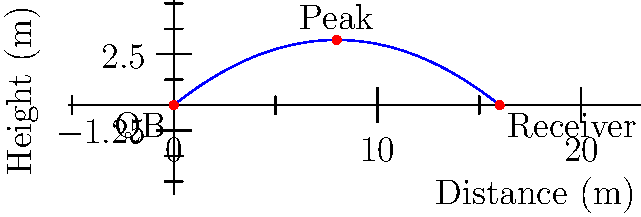A Howard Bison quarterback throws a football with an initial velocity of 20 m/s at an angle of 30° above the horizontal. Assuming air resistance is negligible, what is the maximum height reached by the football during its flight? To find the maximum height of the football, we can follow these steps:

1) First, we need to find the vertical component of the initial velocity:
   $v_{y0} = v_0 \sin \theta = 20 \sin 30° = 20 \cdot 0.5 = 10$ m/s

2) The maximum height is reached when the vertical velocity becomes zero. We can use the equation:
   $v_y^2 = v_{y0}^2 - 2gh_{max}$

   Where $g$ is the acceleration due to gravity (9.8 m/s²) and $h_{max}$ is the maximum height.

3) At the highest point, $v_y = 0$, so:
   $0 = v_{y0}^2 - 2gh_{max}$

4) Rearranging the equation:
   $h_{max} = \frac{v_{y0}^2}{2g}$

5) Substituting the values:
   $h_{max} = \frac{(10 \text{ m/s})^2}{2(9.8 \text{ m/s}^2)} = \frac{100}{19.6} \approx 5.1$ m

Therefore, the maximum height reached by the football is approximately 5.1 meters.
Answer: 5.1 m 